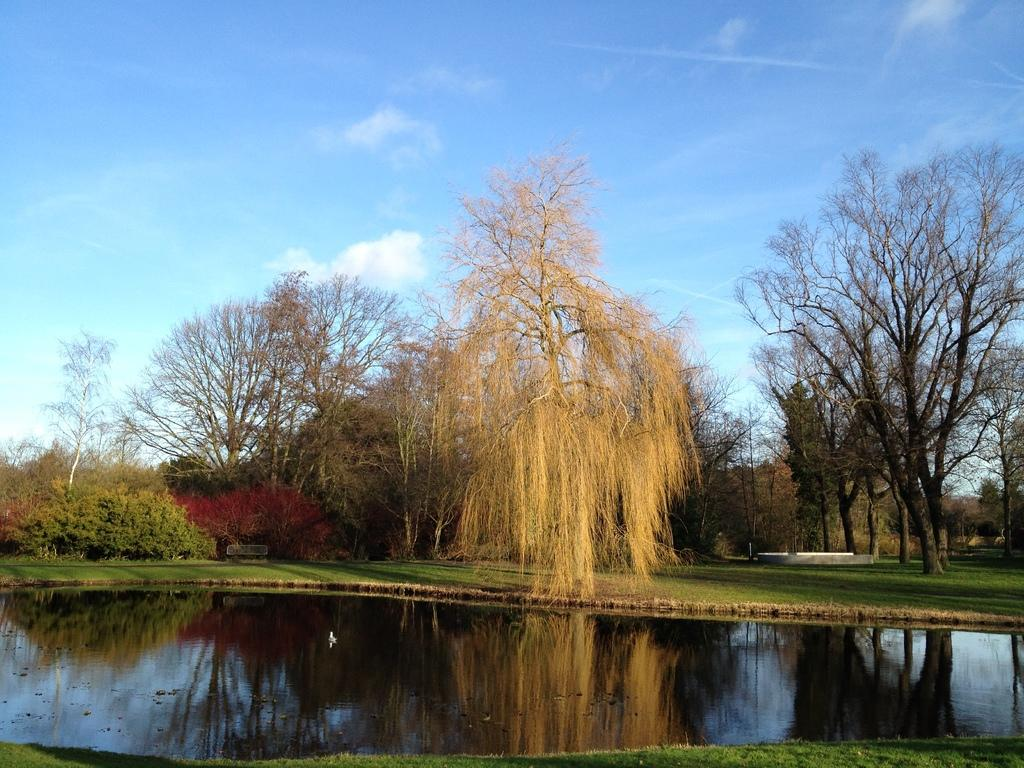What is visible in the image that is not solid? There is water visible in the image. What type of vegetation is present on the ground in the image? There is grass on the ground in the image. What can be seen in the background of the image? There are trees and the sky visible in the background of the image. Where are the flowers and the swing located in the image? There are no flowers or swings present in the image. What stage of development can be observed in the image? The image does not depict any developmental stages; it shows natural elements like water, grass, trees, and the sky. 